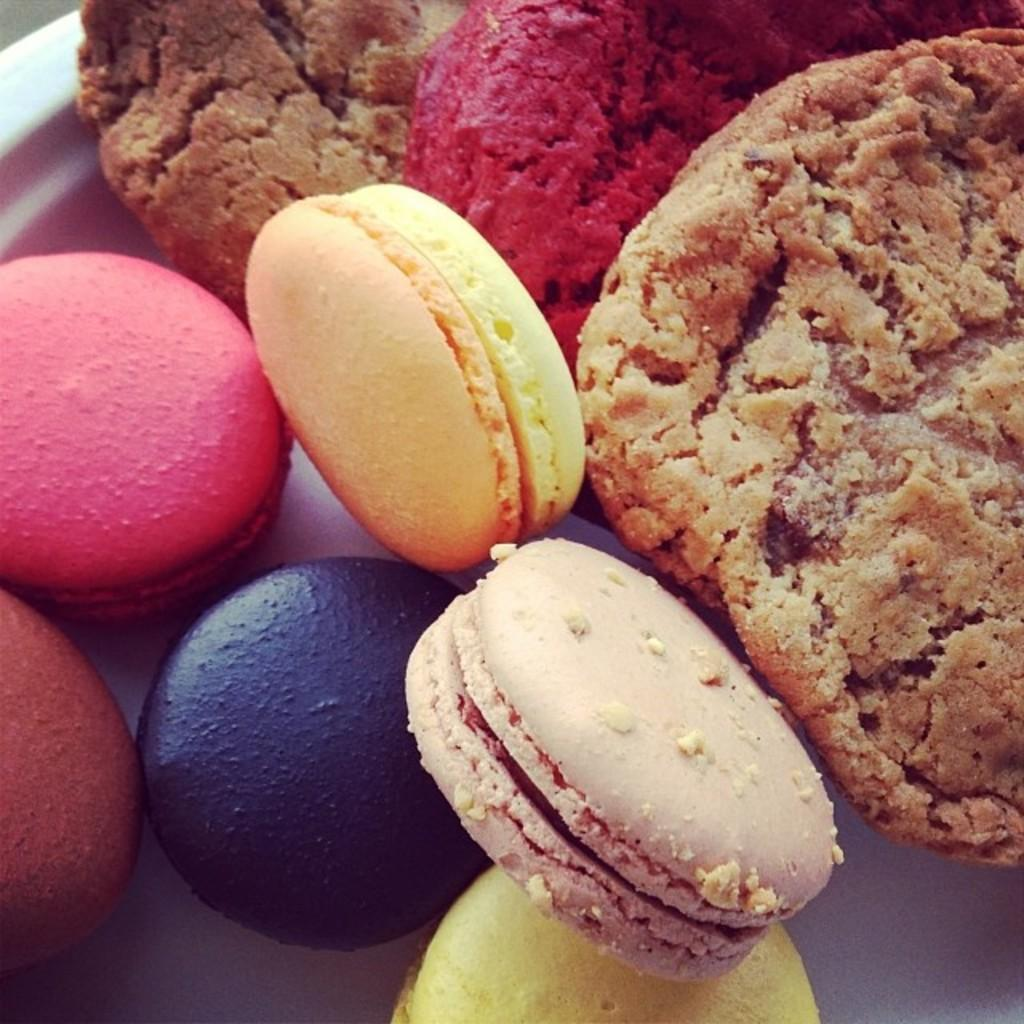What type of biscuits are in the image? There are Macaroon biscuits in the image. What other food items can be seen in the image besides the biscuits? There are other food items in the image, but their specific types are not mentioned in the provided facts. Can you see any snails crawling on the Macaroon biscuits in the image? No, there are no snails present in the image. 